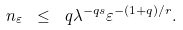Convert formula to latex. <formula><loc_0><loc_0><loc_500><loc_500>n _ { \varepsilon } \ \leq \ q \lambda ^ { - q s } \varepsilon ^ { - ( 1 + q ) / r } .</formula> 